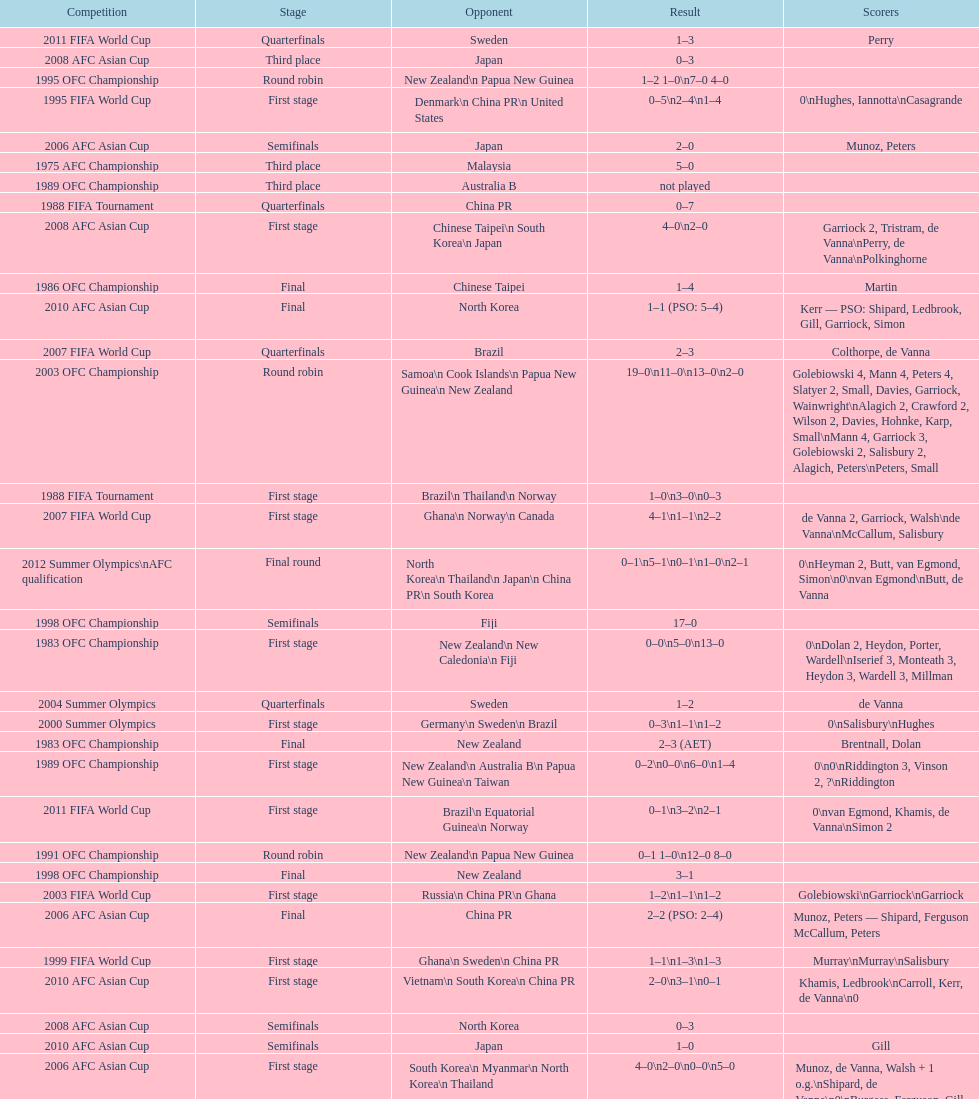What it the total number of countries in the first stage of the 2008 afc asian cup? 4. 